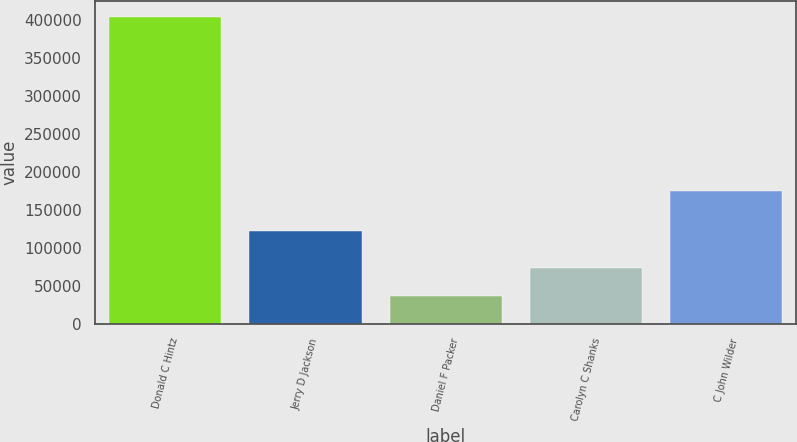Convert chart to OTSL. <chart><loc_0><loc_0><loc_500><loc_500><bar_chart><fcel>Donald C Hintz<fcel>Jerry D Jackson<fcel>Daniel F Packer<fcel>Carolyn C Shanks<fcel>C John Wilder<nl><fcel>405001<fcel>122834<fcel>36534<fcel>73380.7<fcel>175401<nl></chart> 